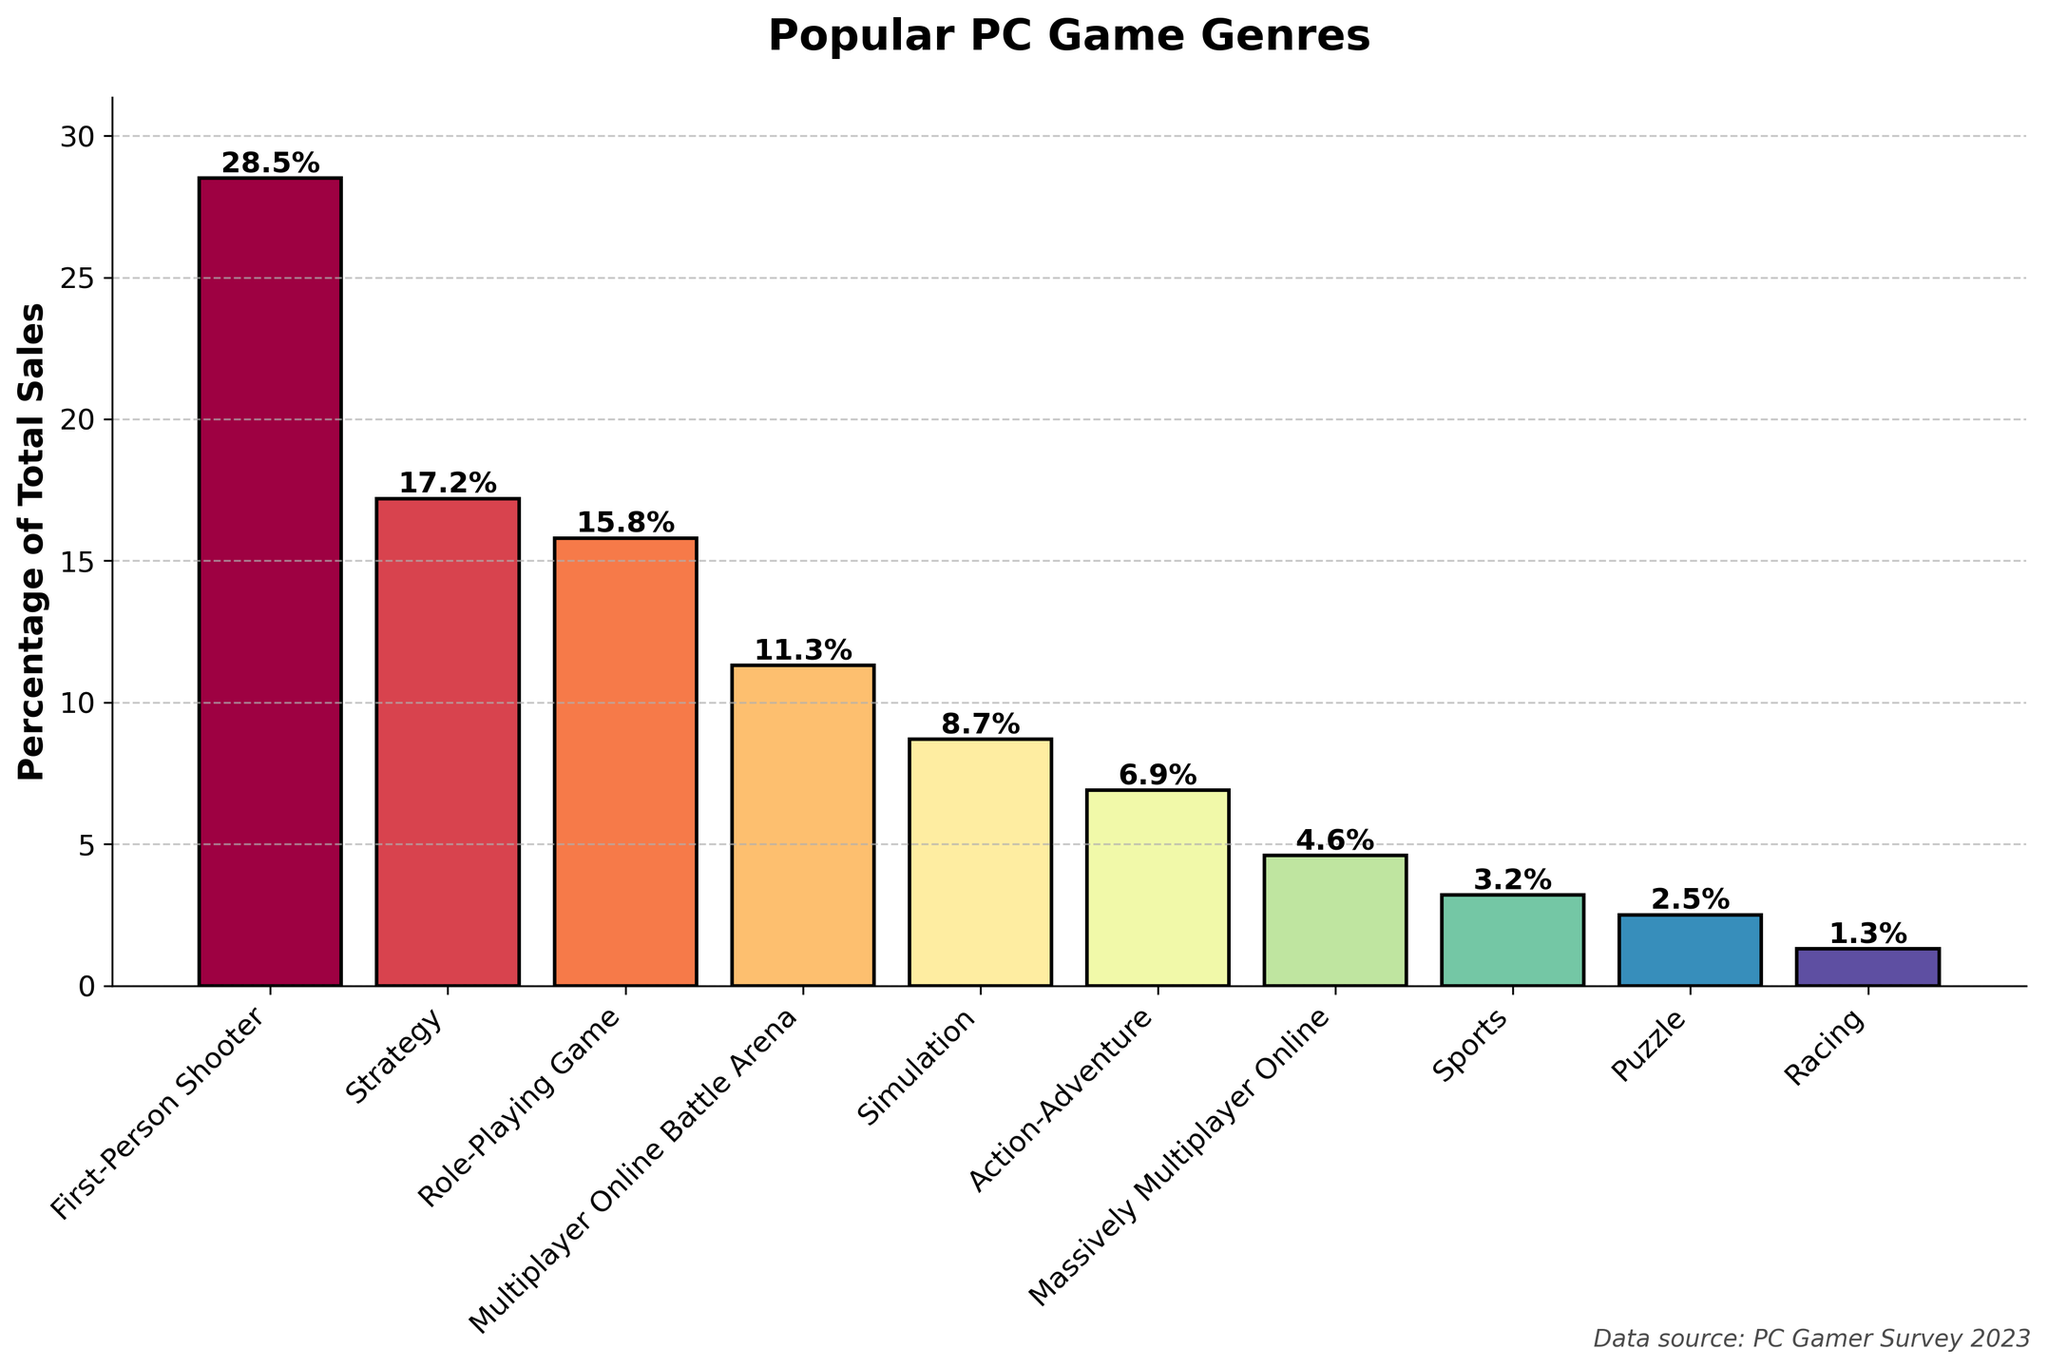What are the top three genres by percentage of total sales? The top percentages in descending order are First-Person Shooter (28.5%), Strategy (17.2%), and Role-Playing Game (15.8%). Therefore, the top three genres are First-Person Shooter, Strategy, and Role-Playing Game.
Answer: First-Person Shooter, Strategy, Role-Playing Game Which genre has the smallest percentage of total sales? The smallest percentage according to the figure is for the Racing genre, which is 1.3%.
Answer: Racing How much more percentage sales does First-Person Shooter have compared to Simulation? Subtract the percentage of Simulation (8.7%) from the percentage of First-Person Shooter (28.5%). The difference is 28.5% - 8.7% = 19.8%.
Answer: 19.8% Which genres have a percentage of total sales more than 10%? Genres with more than 10% are First-Person Shooter (28.5%), Strategy (17.2%), Role-Playing Game (15.8%), and Multiplayer Online Battle Arena (11.3%).
Answer: First-Person Shooter, Strategy, Role-Playing Game, Multiplayer Online Battle Arena What is the combined percentage of the bottom three genres? The percentages for the bottom three genres are Sports (3.2%), Puzzle (2.5%), and Racing (1.3%). Summing them gives 3.2% + 2.5% + 1.3% = 7.0%.
Answer: 7.0% Which genre's bar color appears first when reading the legend from top to bottom in a rainbow-like color spectrum? The color associated with the First-Person Shooter bar appears first as it uses a spectral color map, and the top bar generally is mapped to the first color in a spectral sequence.
Answer: First-Person Shooter Are there more genres with a percentage of total sales above 5% or below 5%? There are 7 genres above 5% (First-Person Shooter, Strategy, Role-Playing Game, Multiplayer Online Battle Arena, Simulation, Action-Adventure, Massively Multiplayer Online) and 3 genres below 5% (Sports, Puzzle, Racing).
Answer: Above 5% What is the percentage difference between Role-Playing Game and Massively Multiplayer Online genres? Subtract the percentage of Massively Multiplayer Online (4.6%) from Role-Playing Game (15.8%). The difference is 15.8% - 4.6% = 11.2%.
Answer: 11.2% Which genres are closest in percentage of total sales? The percentages for Role-Playing Game (15.8%) and Multiplayer Online Battle Arena (11.3%) are close to each other with a difference of 4.5%.
Answer: Role-Playing Game and Multiplayer Online Battle Arena 